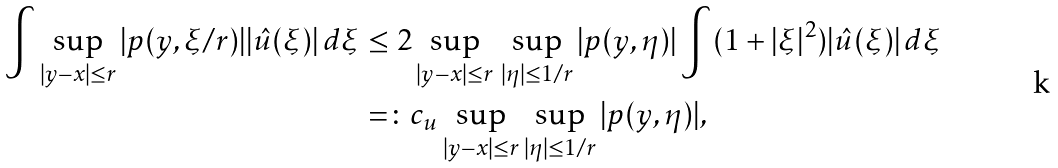Convert formula to latex. <formula><loc_0><loc_0><loc_500><loc_500>\int \sup _ { | y - x | \leq r } | p ( y , \xi / r ) | | \hat { u } ( \xi ) | \, d \xi & \leq 2 \sup _ { | y - x | \leq r } \, \sup _ { | \eta | \leq 1 / r } | p ( y , \eta ) | \int ( 1 + | \xi | ^ { 2 } ) | \hat { u } ( \xi ) | \, d \xi \\ & = \colon c _ { u } \sup _ { | y - x | \leq r } \sup _ { | \eta | \leq 1 / r } | p ( y , \eta ) | ,</formula> 